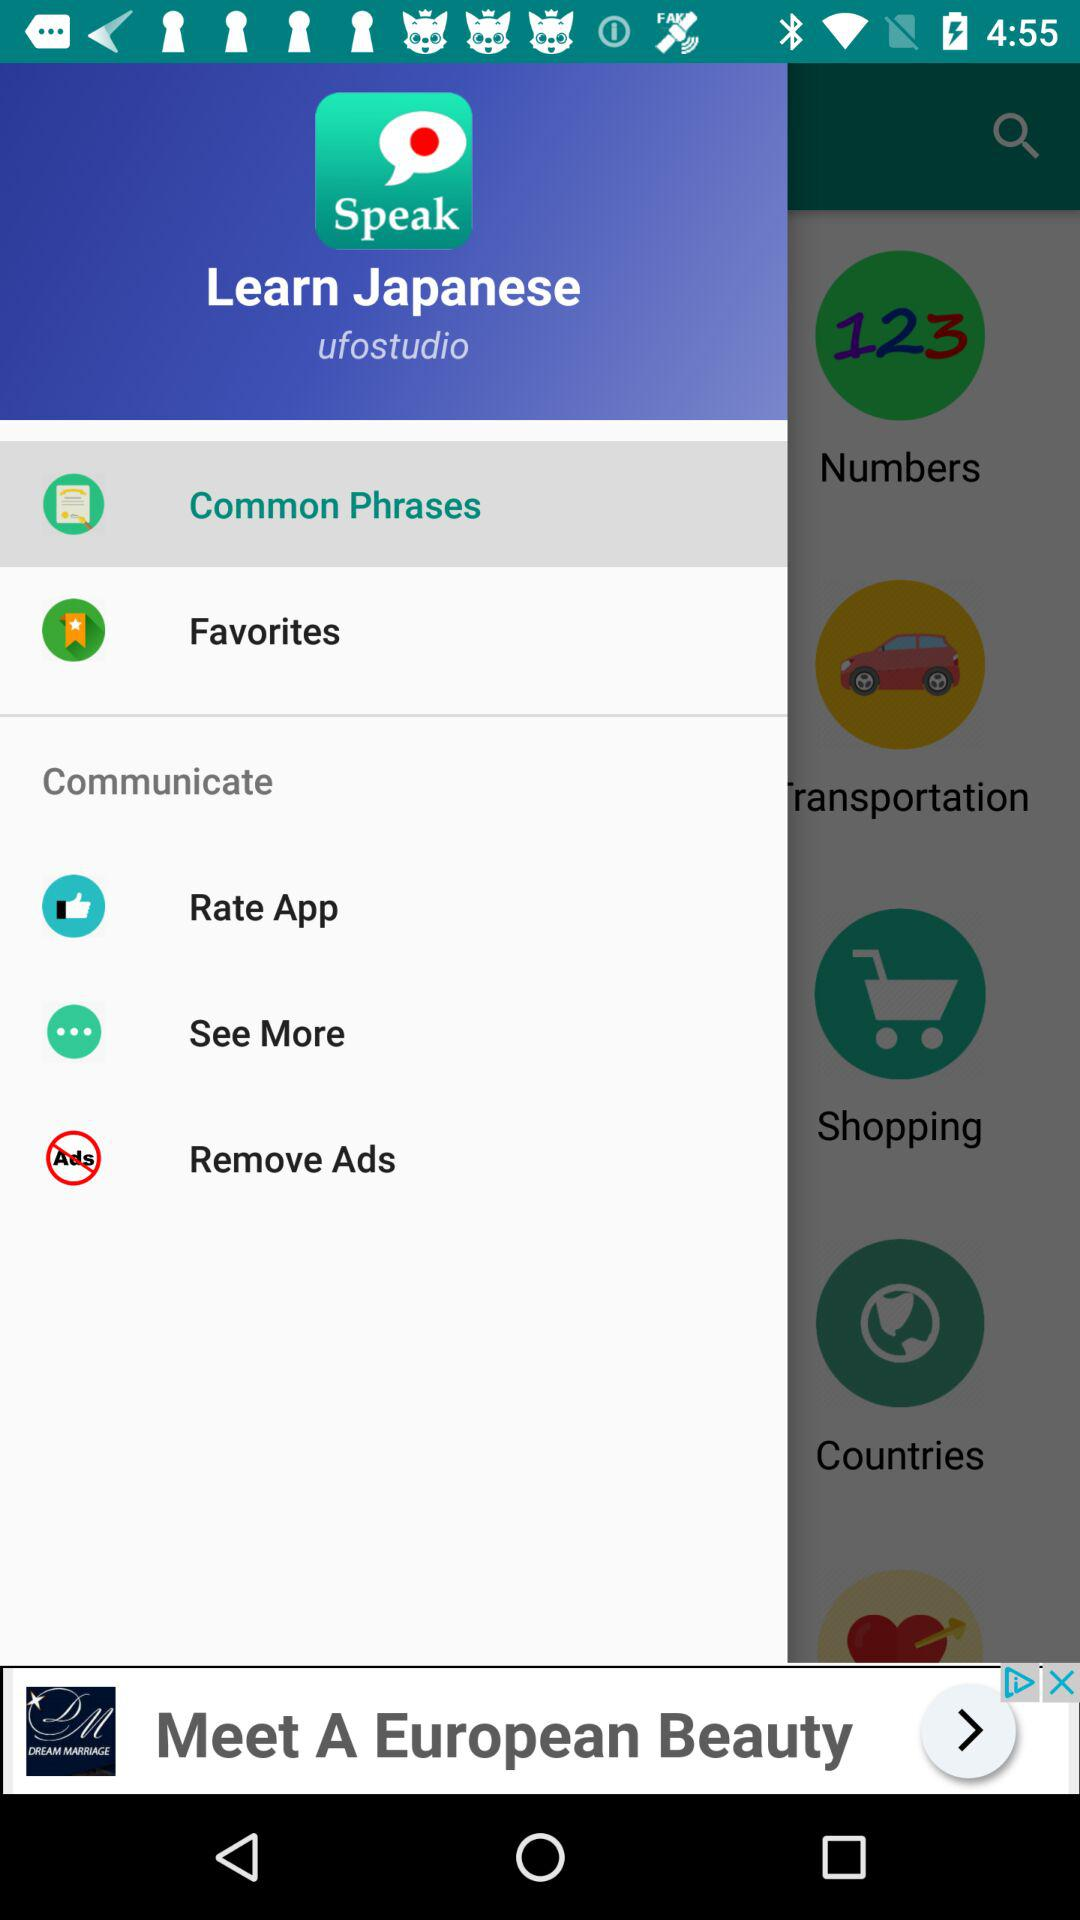What is the selected option? The selected option is "Common Phrases". 